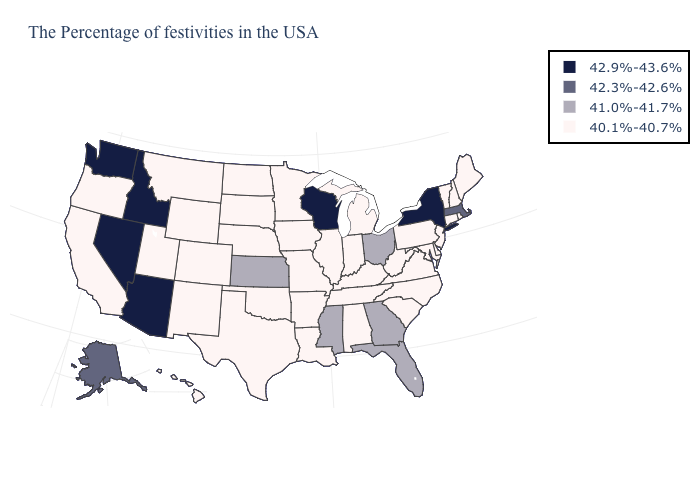Does New York have the lowest value in the USA?
Answer briefly. No. What is the value of Arizona?
Answer briefly. 42.9%-43.6%. What is the value of California?
Keep it brief. 40.1%-40.7%. Name the states that have a value in the range 41.0%-41.7%?
Concise answer only. Ohio, Florida, Georgia, Mississippi, Kansas. Does Maryland have the highest value in the USA?
Keep it brief. No. Which states have the lowest value in the USA?
Give a very brief answer. Maine, Rhode Island, New Hampshire, Vermont, Connecticut, New Jersey, Delaware, Maryland, Pennsylvania, Virginia, North Carolina, South Carolina, West Virginia, Michigan, Kentucky, Indiana, Alabama, Tennessee, Illinois, Louisiana, Missouri, Arkansas, Minnesota, Iowa, Nebraska, Oklahoma, Texas, South Dakota, North Dakota, Wyoming, Colorado, New Mexico, Utah, Montana, California, Oregon, Hawaii. Does the first symbol in the legend represent the smallest category?
Short answer required. No. Among the states that border Illinois , does Iowa have the lowest value?
Give a very brief answer. Yes. What is the lowest value in states that border Kansas?
Short answer required. 40.1%-40.7%. Does the map have missing data?
Answer briefly. No. Does Massachusetts have the highest value in the USA?
Give a very brief answer. No. Does New Hampshire have the same value as Ohio?
Keep it brief. No. What is the highest value in states that border Washington?
Keep it brief. 42.9%-43.6%. Does the first symbol in the legend represent the smallest category?
Keep it brief. No. Which states have the lowest value in the USA?
Answer briefly. Maine, Rhode Island, New Hampshire, Vermont, Connecticut, New Jersey, Delaware, Maryland, Pennsylvania, Virginia, North Carolina, South Carolina, West Virginia, Michigan, Kentucky, Indiana, Alabama, Tennessee, Illinois, Louisiana, Missouri, Arkansas, Minnesota, Iowa, Nebraska, Oklahoma, Texas, South Dakota, North Dakota, Wyoming, Colorado, New Mexico, Utah, Montana, California, Oregon, Hawaii. 